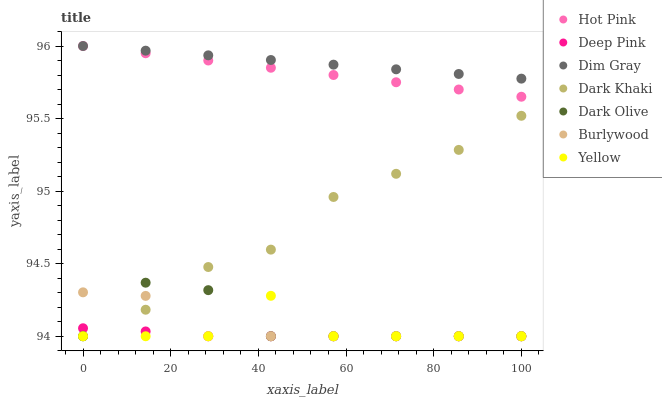Does Deep Pink have the minimum area under the curve?
Answer yes or no. Yes. Does Dim Gray have the maximum area under the curve?
Answer yes or no. Yes. Does Burlywood have the minimum area under the curve?
Answer yes or no. No. Does Burlywood have the maximum area under the curve?
Answer yes or no. No. Is Dim Gray the smoothest?
Answer yes or no. Yes. Is Yellow the roughest?
Answer yes or no. Yes. Is Burlywood the smoothest?
Answer yes or no. No. Is Burlywood the roughest?
Answer yes or no. No. Does Burlywood have the lowest value?
Answer yes or no. Yes. Does Hot Pink have the lowest value?
Answer yes or no. No. Does Hot Pink have the highest value?
Answer yes or no. Yes. Does Burlywood have the highest value?
Answer yes or no. No. Is Dark Olive less than Hot Pink?
Answer yes or no. Yes. Is Hot Pink greater than Dark Khaki?
Answer yes or no. Yes. Does Burlywood intersect Deep Pink?
Answer yes or no. Yes. Is Burlywood less than Deep Pink?
Answer yes or no. No. Is Burlywood greater than Deep Pink?
Answer yes or no. No. Does Dark Olive intersect Hot Pink?
Answer yes or no. No. 